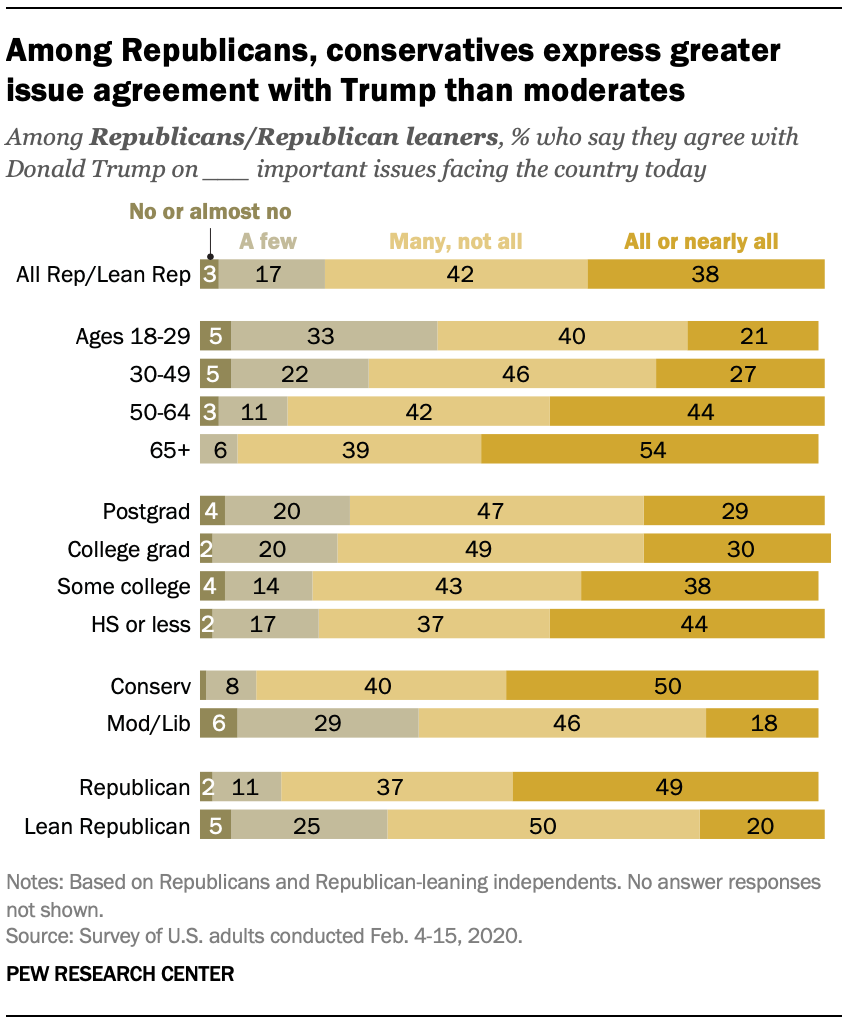Specify some key components in this picture. Among Republican or Republican-leaning adults aged 65 and older, 39% agree with at least some of the important issues facing the country. A majority of Republican/leaning Republicans, at 42%, agree with many but not all of the important issues facing the country. 